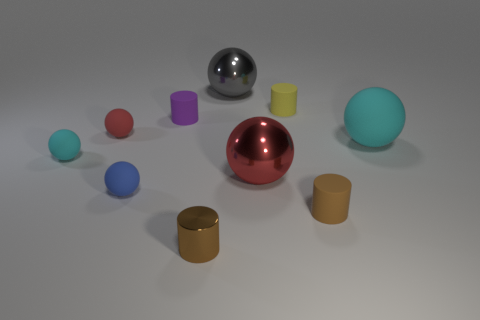There is a purple cylinder; are there any red balls left of it?
Provide a succinct answer. Yes. What is the shape of the large gray object?
Your response must be concise. Sphere. What number of things are either small things in front of the small cyan matte sphere or blue matte balls?
Provide a short and direct response. 3. How many other objects are the same color as the small shiny cylinder?
Provide a succinct answer. 1. There is a tiny metallic cylinder; does it have the same color as the big object that is to the right of the small brown matte cylinder?
Make the answer very short. No. What color is the metallic object that is the same shape as the small brown matte thing?
Offer a very short reply. Brown. Do the purple thing and the brown object that is to the left of the big gray metal ball have the same material?
Make the answer very short. No. The large matte sphere has what color?
Your answer should be compact. Cyan. What color is the metallic object behind the cyan matte sphere that is right of the large sphere that is behind the purple cylinder?
Your response must be concise. Gray. Is the shape of the tiny blue rubber thing the same as the shiny object behind the yellow cylinder?
Offer a very short reply. Yes. 